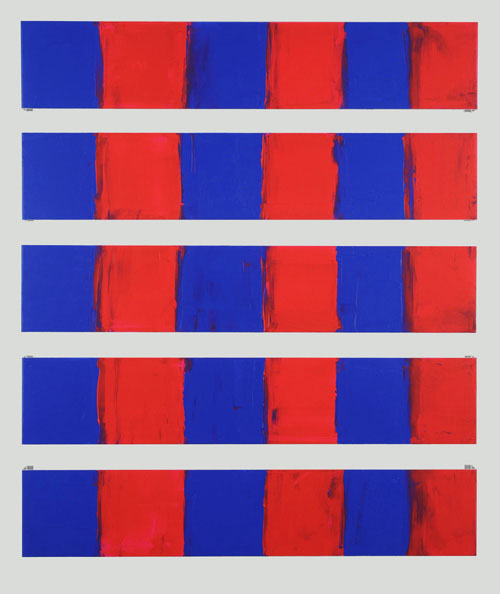Explain the visual content of the image in great detail. The image features a compelling abstract composition of nine rectangular panels, systematically arranged in three rows. Each panel contrasts vibrant red and deep blue colors, divided vertically. The red paint appears thick and textured, suggesting an expressive application with a palette knife or brush, while the blue areas are smoother. This stark contrast may evoke varied emotional responses, potentially representing thematic dichotomies such as warmth vs. coolness or conflict vs. serenity. The structure exudes a rhythmic quality, inviting viewers to ponder the relationship between repetition and variation in abstract art. 